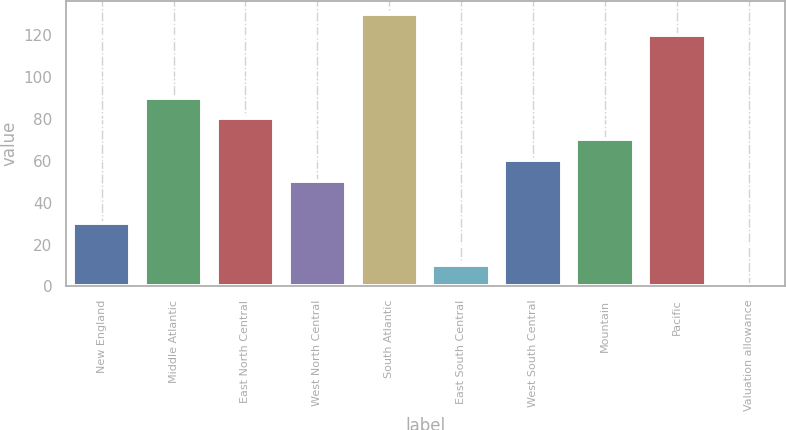Convert chart to OTSL. <chart><loc_0><loc_0><loc_500><loc_500><bar_chart><fcel>New England<fcel>Middle Atlantic<fcel>East North Central<fcel>West North Central<fcel>South Atlantic<fcel>East South Central<fcel>West South Central<fcel>Mountain<fcel>Pacific<fcel>Valuation allowance<nl><fcel>30.35<fcel>90.05<fcel>80.1<fcel>50.25<fcel>129.85<fcel>10.45<fcel>60.2<fcel>70.15<fcel>119.9<fcel>0.5<nl></chart> 